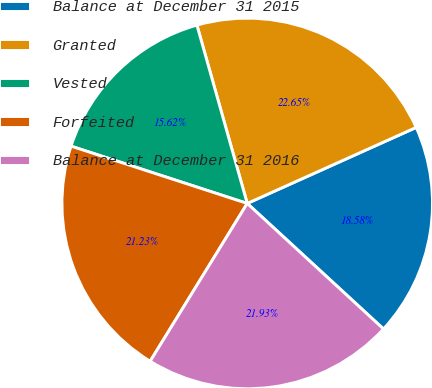<chart> <loc_0><loc_0><loc_500><loc_500><pie_chart><fcel>Balance at December 31 2015<fcel>Granted<fcel>Vested<fcel>Forfeited<fcel>Balance at December 31 2016<nl><fcel>18.58%<fcel>22.65%<fcel>15.62%<fcel>21.23%<fcel>21.93%<nl></chart> 